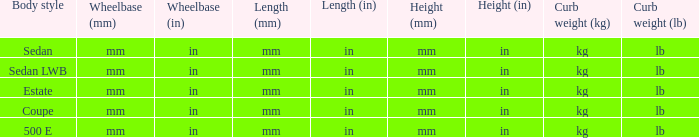What are the lengths of the models that are mm (in) tall? Mm (in), mm (in). 